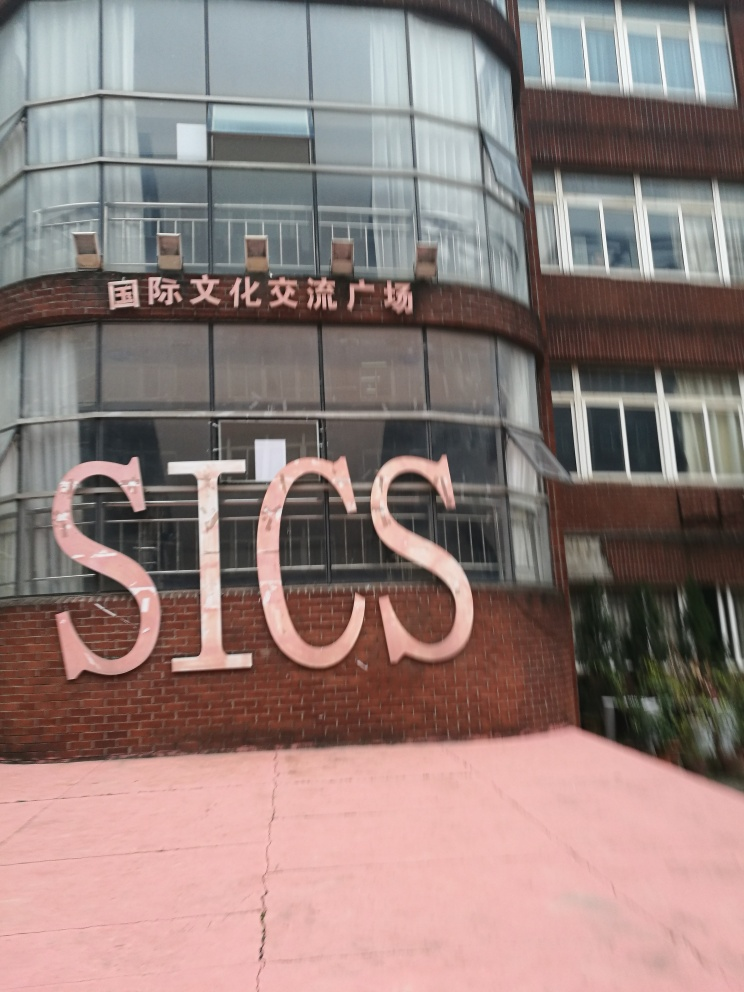Is the building in this image used for commercial or educational purposes? Based on the image, it's challenging to definitively say whether the building is used for commercial or educational purposes. The presence of signage in a non-English language suggests it might be an institution located in a country where that language is spoken. A further clue could be provided by the style of the building, which seems utilitarian and might be indicative of an educational institution. 